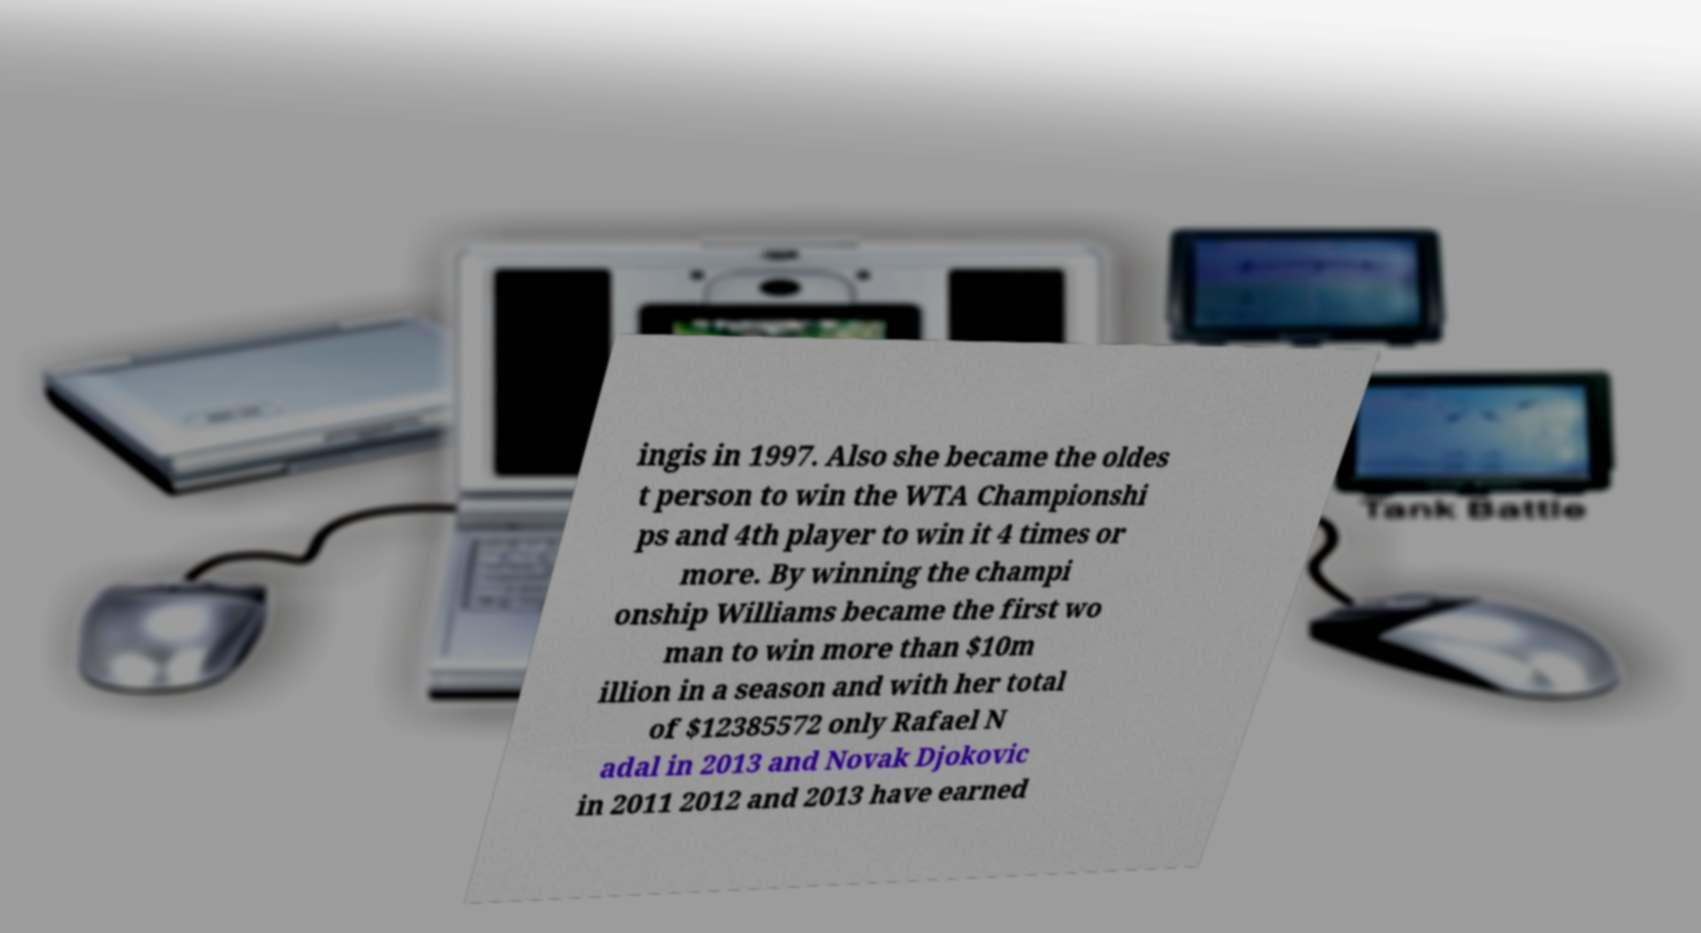There's text embedded in this image that I need extracted. Can you transcribe it verbatim? ingis in 1997. Also she became the oldes t person to win the WTA Championshi ps and 4th player to win it 4 times or more. By winning the champi onship Williams became the first wo man to win more than $10m illion in a season and with her total of $12385572 only Rafael N adal in 2013 and Novak Djokovic in 2011 2012 and 2013 have earned 